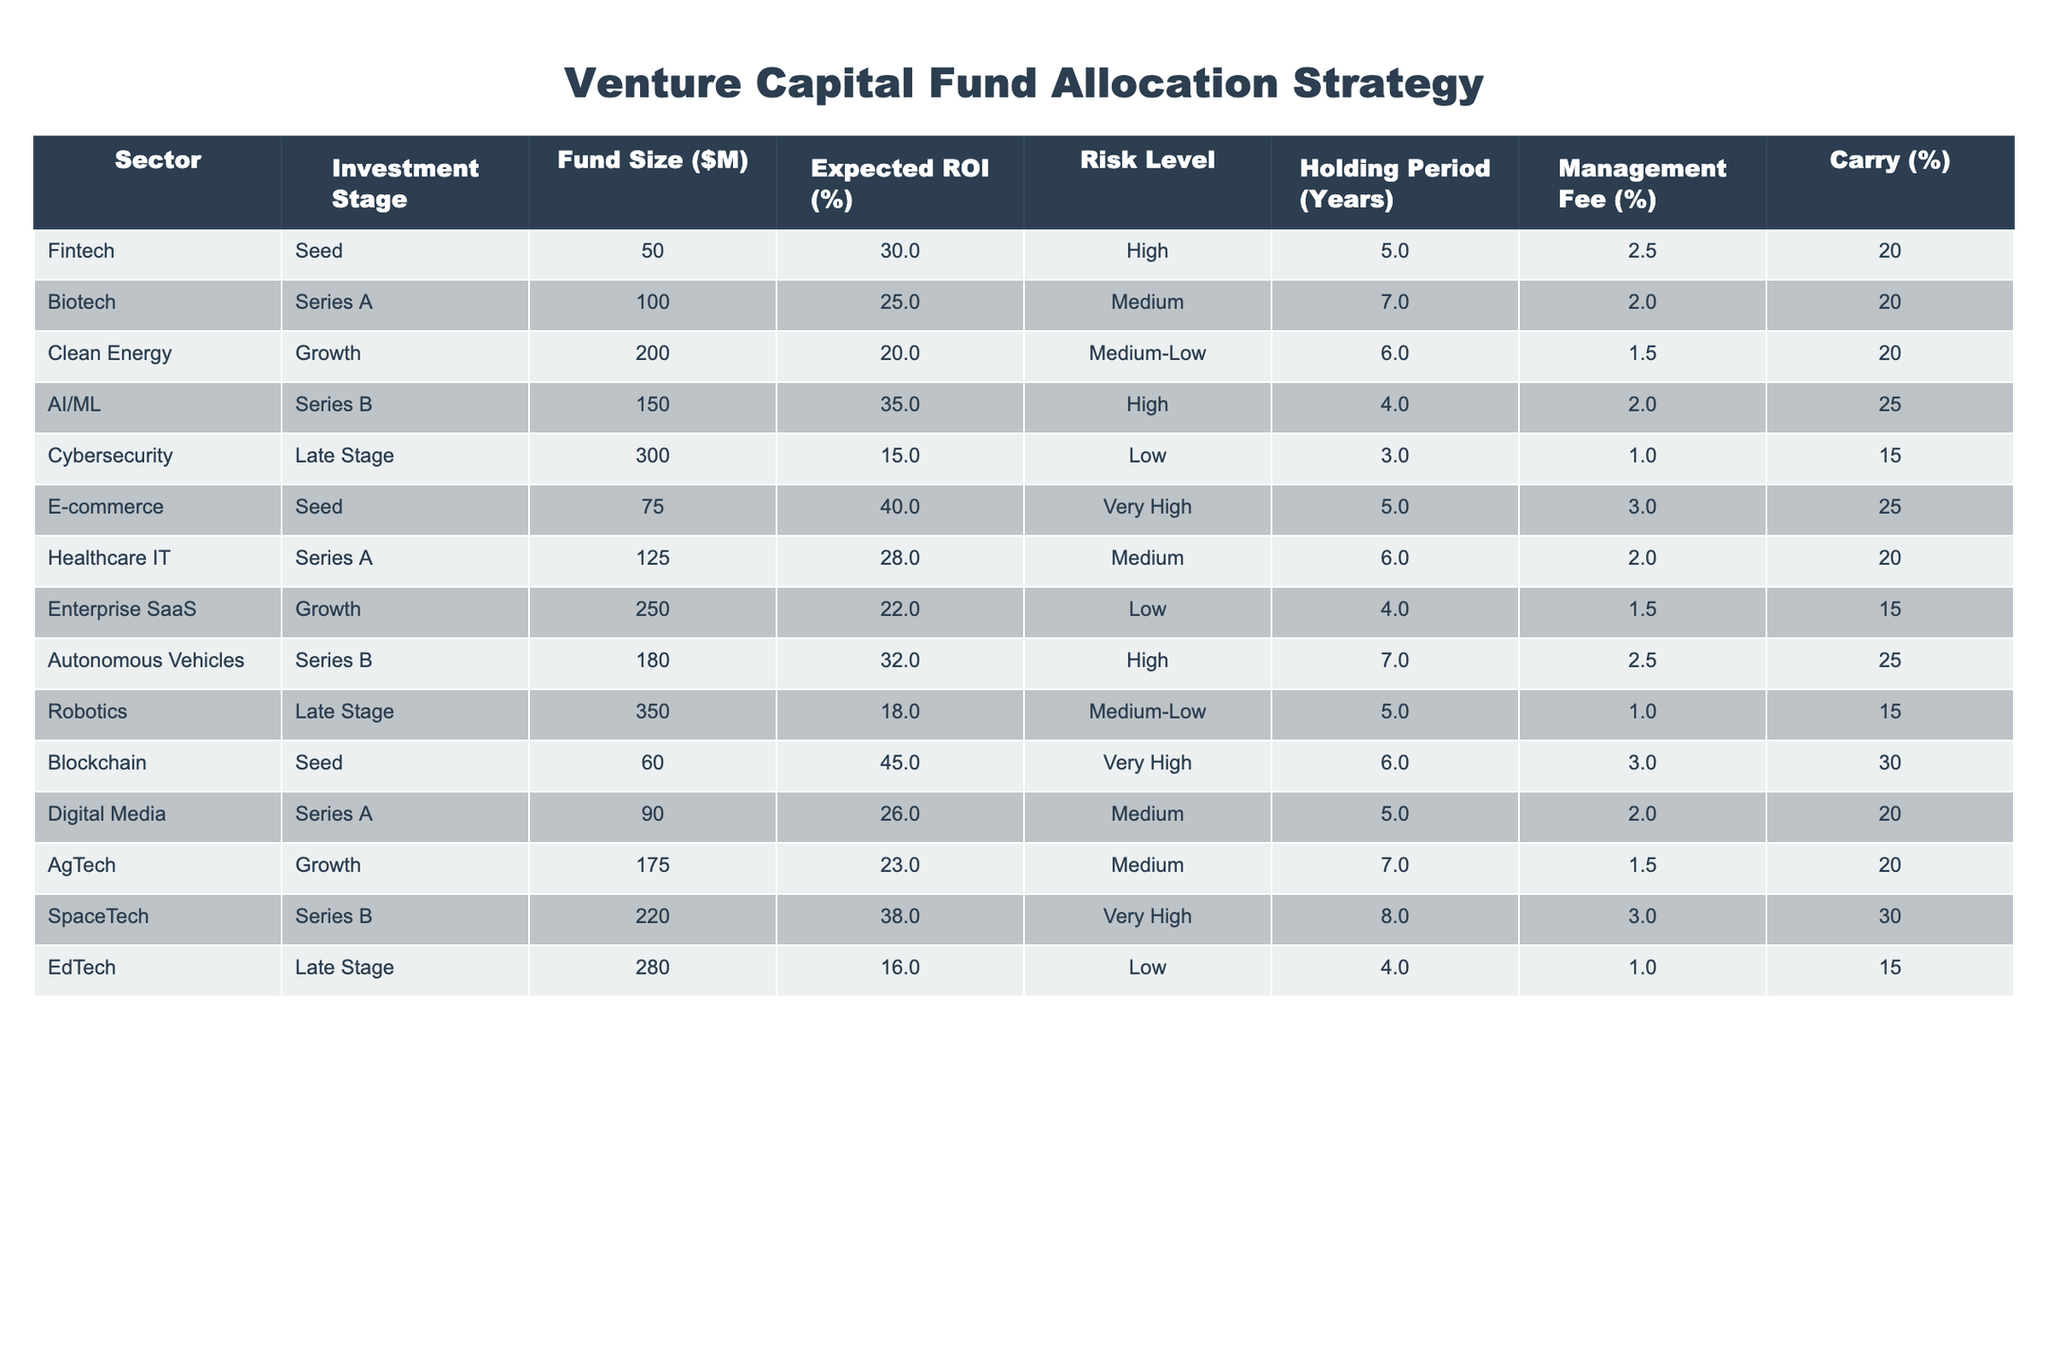What is the expected ROI for E-commerce investments? The expected ROI for E-commerce investments in the table is listed under the Expected ROI (%) column. Looking at the row for E-commerce, the value is 40%.
Answer: 40% Which sector has the highest management fee percentage? To find the sector with the highest management fee percentage, we need to look at the Management Fee (%) column and compare the values. The comparison shows that Blockchain has the highest management fee at 3%.
Answer: Blockchain What is the difference in Fund Size between the largest and smallest investment opportunities? The largest Fund Size listed is 350 million for Robotics, and the smallest is 50 million for Fintech. The difference can be calculated as 350 - 50 = 300 million.
Answer: 300 million Are there any investments in the Late Stage that have an Expected ROI greater than 20%? We need to check the Late Stage investments and their corresponding Expected ROI. The investments listed are Cybersecurity (15%), Robotics (18%), and EdTech (16%). All are below 20%, so the answer is no.
Answer: No What is the average Holding Period for investments in the Seed stage? We look for the Seed stage entries in the Holding Period (Years) column. The entries are 5 years for both E-commerce and Fintech, and 6 years for Blockchain. We calculate the average by summing these values (5 + 5 + 6 = 16) and dividing by the number of entries (3), which gives an average of 16/3 = approximately 5.33 years.
Answer: 5.33 years Which sector has the lowest Expected ROI and what is that ROI? We need to find the sector with the lowest expected return by examining the Expected ROI (%) column. The lowest value identified in the table is 15% for Cybersecurity.
Answer: Cybersecurity, 15% How many investment opportunities have a Risk Level categorized as High? We count the number of entries listed under the Risk Level that state "High." The sectors that meet this criterion are Fintech, AI/ML, and Autonomous Vehicles, totaling three opportunities.
Answer: 3 Is there an investment opportunity in Clean Energy with a Carry percentage smaller than 20%? To answer this, we check the Clean Energy entry for its Carry (%) value, which is 20%. Therefore, there is no investment opportunity with a Carry percentage smaller than 20%.
Answer: No What is the total expected ROI for Series A investments? We identify the Series A investment opportunities and sum their Expected ROI values. The values are 25% for Biotech, 28% for Healthcare IT, and 26% for Digital Media, resulting in the calculation of total ROI as 25 + 28 + 26 = 79%.
Answer: 79% 